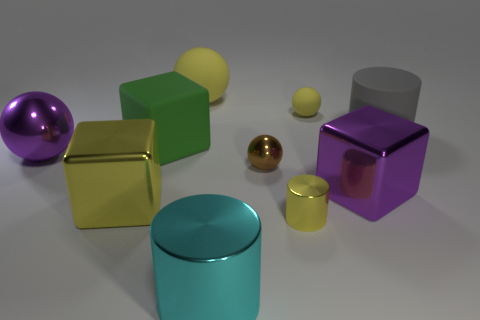How many yellow spheres must be subtracted to get 1 yellow spheres? 1 Subtract all brown balls. How many balls are left? 3 Add 5 large gray cylinders. How many large gray cylinders exist? 6 Subtract all rubber cylinders. How many cylinders are left? 2 Subtract 1 yellow cubes. How many objects are left? 9 Subtract all cubes. How many objects are left? 7 Subtract all green cubes. Subtract all blue cylinders. How many cubes are left? 2 Subtract all yellow blocks. How many purple spheres are left? 1 Subtract all brown metal things. Subtract all small objects. How many objects are left? 6 Add 1 yellow cylinders. How many yellow cylinders are left? 2 